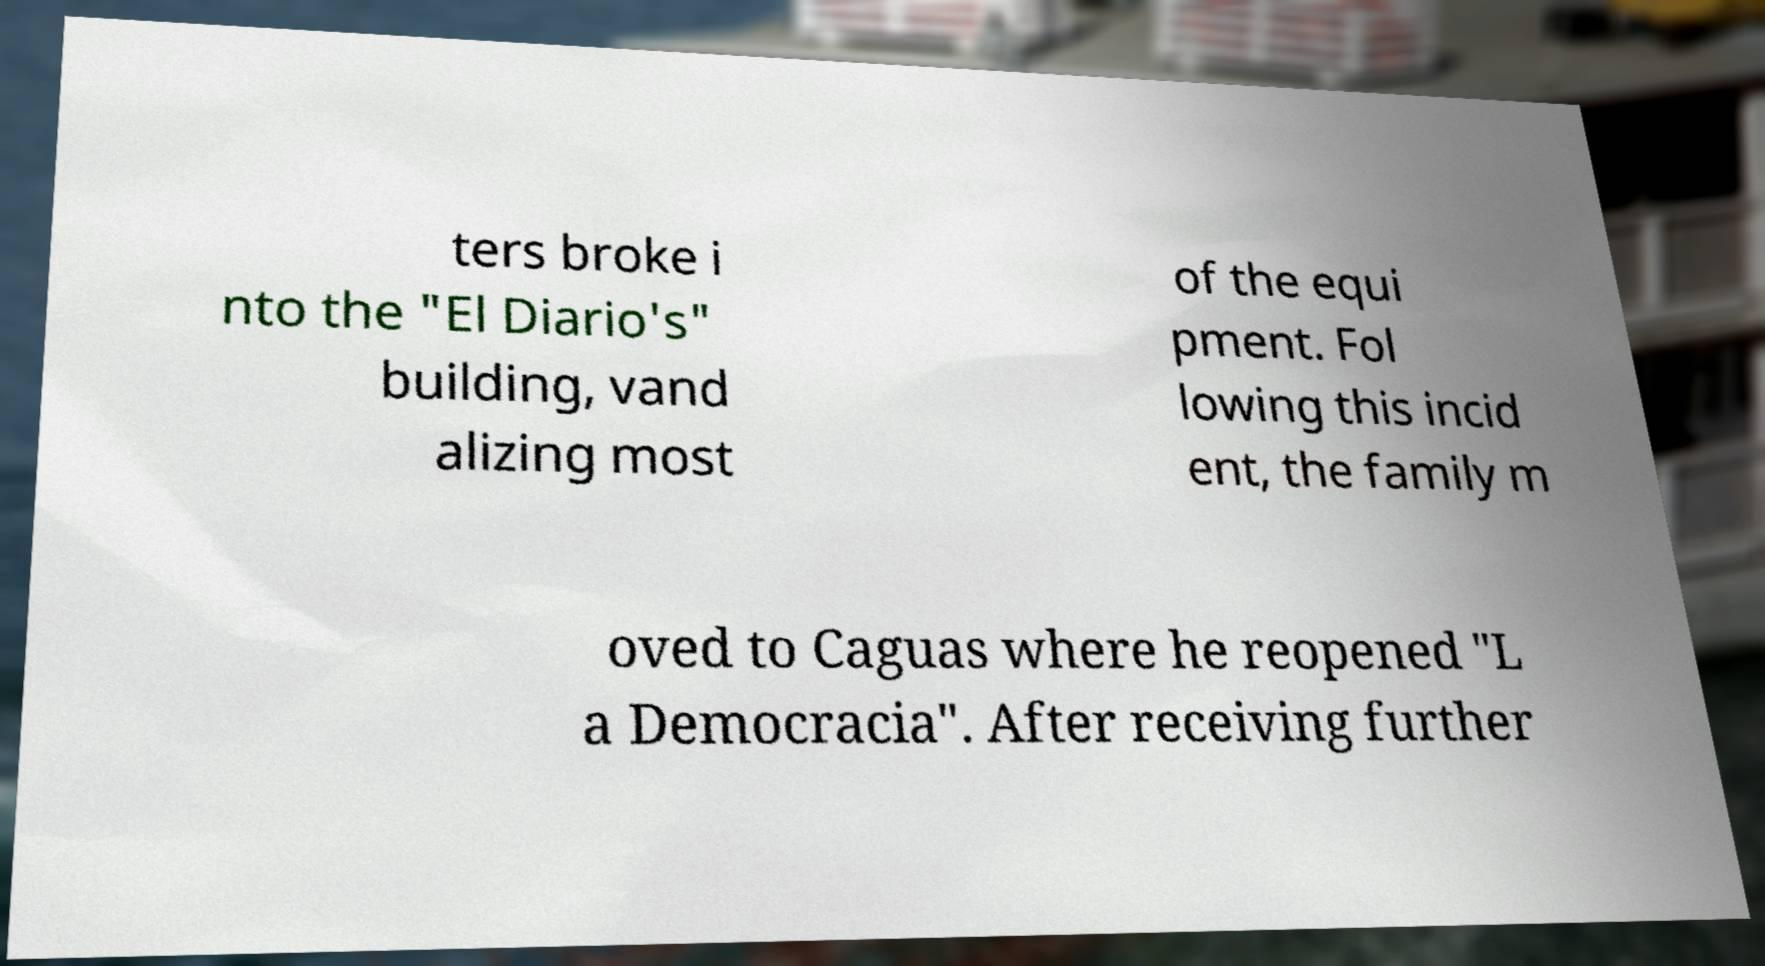What messages or text are displayed in this image? I need them in a readable, typed format. ters broke i nto the "El Diario's" building, vand alizing most of the equi pment. Fol lowing this incid ent, the family m oved to Caguas where he reopened "L a Democracia". After receiving further 